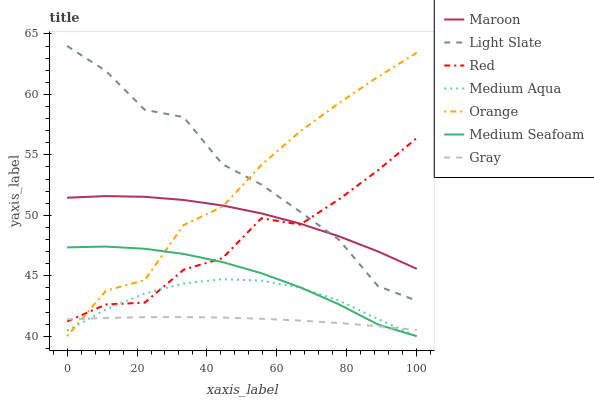Does Gray have the minimum area under the curve?
Answer yes or no. Yes. Does Light Slate have the maximum area under the curve?
Answer yes or no. Yes. Does Maroon have the minimum area under the curve?
Answer yes or no. No. Does Maroon have the maximum area under the curve?
Answer yes or no. No. Is Gray the smoothest?
Answer yes or no. Yes. Is Red the roughest?
Answer yes or no. Yes. Is Light Slate the smoothest?
Answer yes or no. No. Is Light Slate the roughest?
Answer yes or no. No. Does Medium Aqua have the lowest value?
Answer yes or no. Yes. Does Light Slate have the lowest value?
Answer yes or no. No. Does Light Slate have the highest value?
Answer yes or no. Yes. Does Maroon have the highest value?
Answer yes or no. No. Is Gray less than Maroon?
Answer yes or no. Yes. Is Maroon greater than Medium Seafoam?
Answer yes or no. Yes. Does Medium Seafoam intersect Red?
Answer yes or no. Yes. Is Medium Seafoam less than Red?
Answer yes or no. No. Is Medium Seafoam greater than Red?
Answer yes or no. No. Does Gray intersect Maroon?
Answer yes or no. No. 